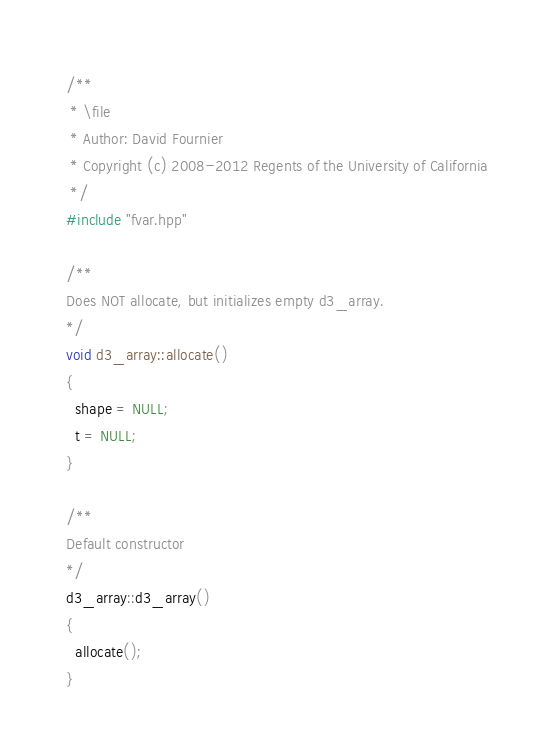Convert code to text. <code><loc_0><loc_0><loc_500><loc_500><_C++_>/**
 * \file
 * Author: David Fournier
 * Copyright (c) 2008-2012 Regents of the University of California
 */
#include "fvar.hpp"

/**
Does NOT allocate, but initializes empty d3_array.
*/
void d3_array::allocate()
{
  shape = NULL;
  t = NULL;
}

/**
Default constructor
*/
d3_array::d3_array()
{
  allocate();
}
</code> 